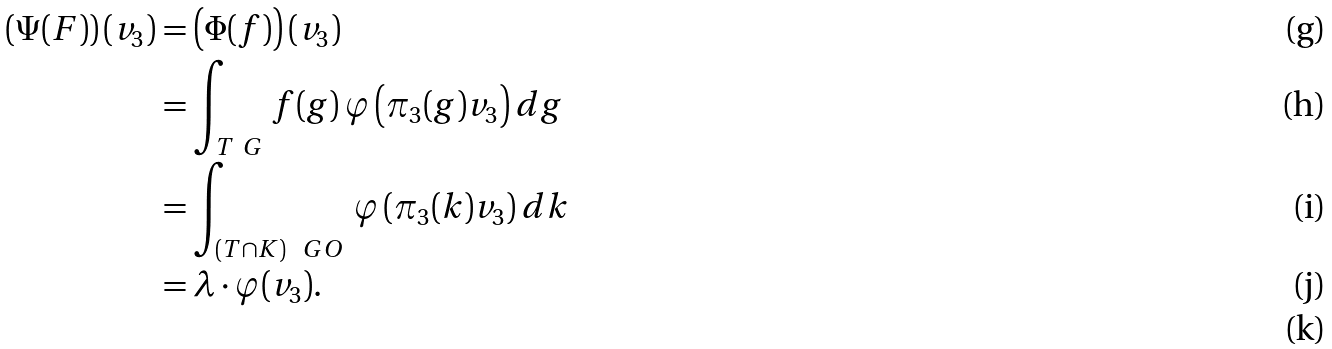Convert formula to latex. <formula><loc_0><loc_0><loc_500><loc_500>\left ( \Psi ( F ) \right ) ( v _ { 3 } ) & = \left ( \Phi ( f ) \right ) ( v _ { 3 } ) \\ & = \int _ { T \ G } \, f ( g ) \, \varphi \left ( \pi _ { 3 } ( g ) v _ { 3 } \right ) d g \\ & = \int _ { ( T \cap K ) \ \ G O } \, \varphi \left ( \pi _ { 3 } ( k ) v _ { 3 } \right ) d k \\ & = \lambda \cdot \varphi ( v _ { 3 } ) . \\</formula> 